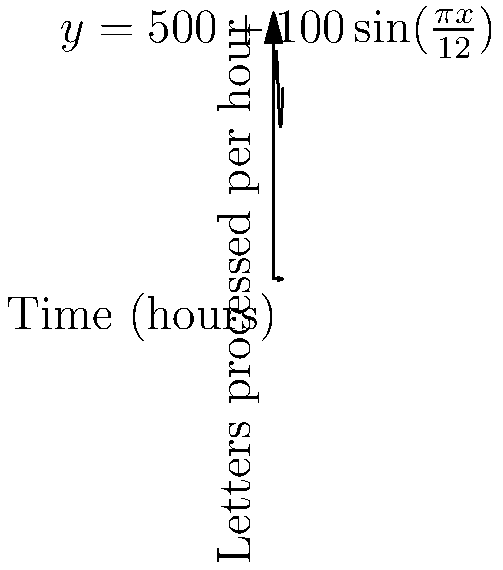The graph shows the rate at which letters are processed in a post office over a 24-hour period, given by the function $f(x)=500+100\sin(\frac{\pi x}{12})$, where $x$ is the time in hours and $f(x)$ is the number of letters processed per hour. Calculate the total number of letters processed during this 24-hour period. To find the total number of letters processed, we need to calculate the area under the curve, which is given by the definite integral of the function over the 24-hour period.

1) The integral we need to evaluate is:
   $$\int_0^{24} (500+100\sin(\frac{\pi x}{12})) dx$$

2) Let's break this into two parts:
   $$\int_0^{24} 500 dx + \int_0^{24} 100\sin(\frac{\pi x}{12}) dx$$

3) For the first part:
   $$\int_0^{24} 500 dx = 500x \Big|_0^{24} = 500(24) - 500(0) = 12000$$

4) For the second part, we use the substitution $u = \frac{\pi x}{12}$:
   $$\int_0^{24} 100\sin(\frac{\pi x}{12}) dx = \frac{1200}{\pi} \int_0^{2\pi} \sin(u) du$$

5) We know that $\int \sin(u) du = -\cos(u) + C$, so:
   $$\frac{1200}{\pi} \int_0^{2\pi} \sin(u) du = \frac{1200}{\pi} [-\cos(u)]_0^{2\pi} = \frac{1200}{\pi} [(-\cos(2\pi)) - (-\cos(0))] = 0$$

6) Adding the results from steps 3 and 5:
   Total letters processed = 12000 + 0 = 12000
Answer: 12000 letters 